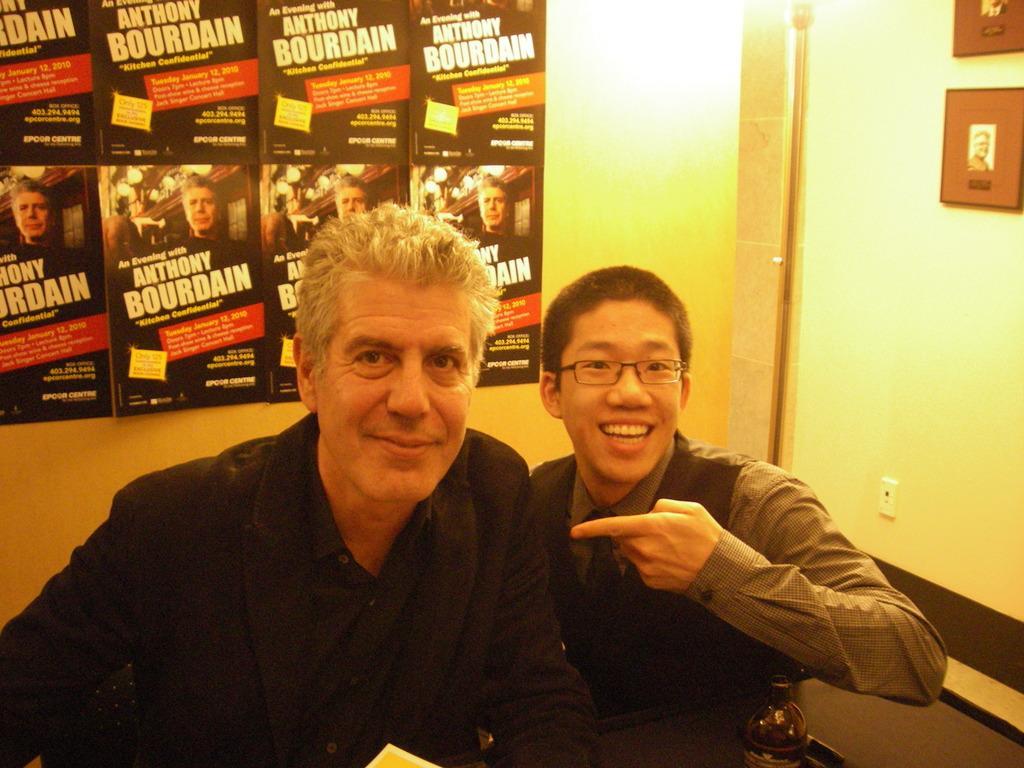Please provide a concise description of this image. In this picture there are two men in the center of the image and there are posters in the background area of the image. 